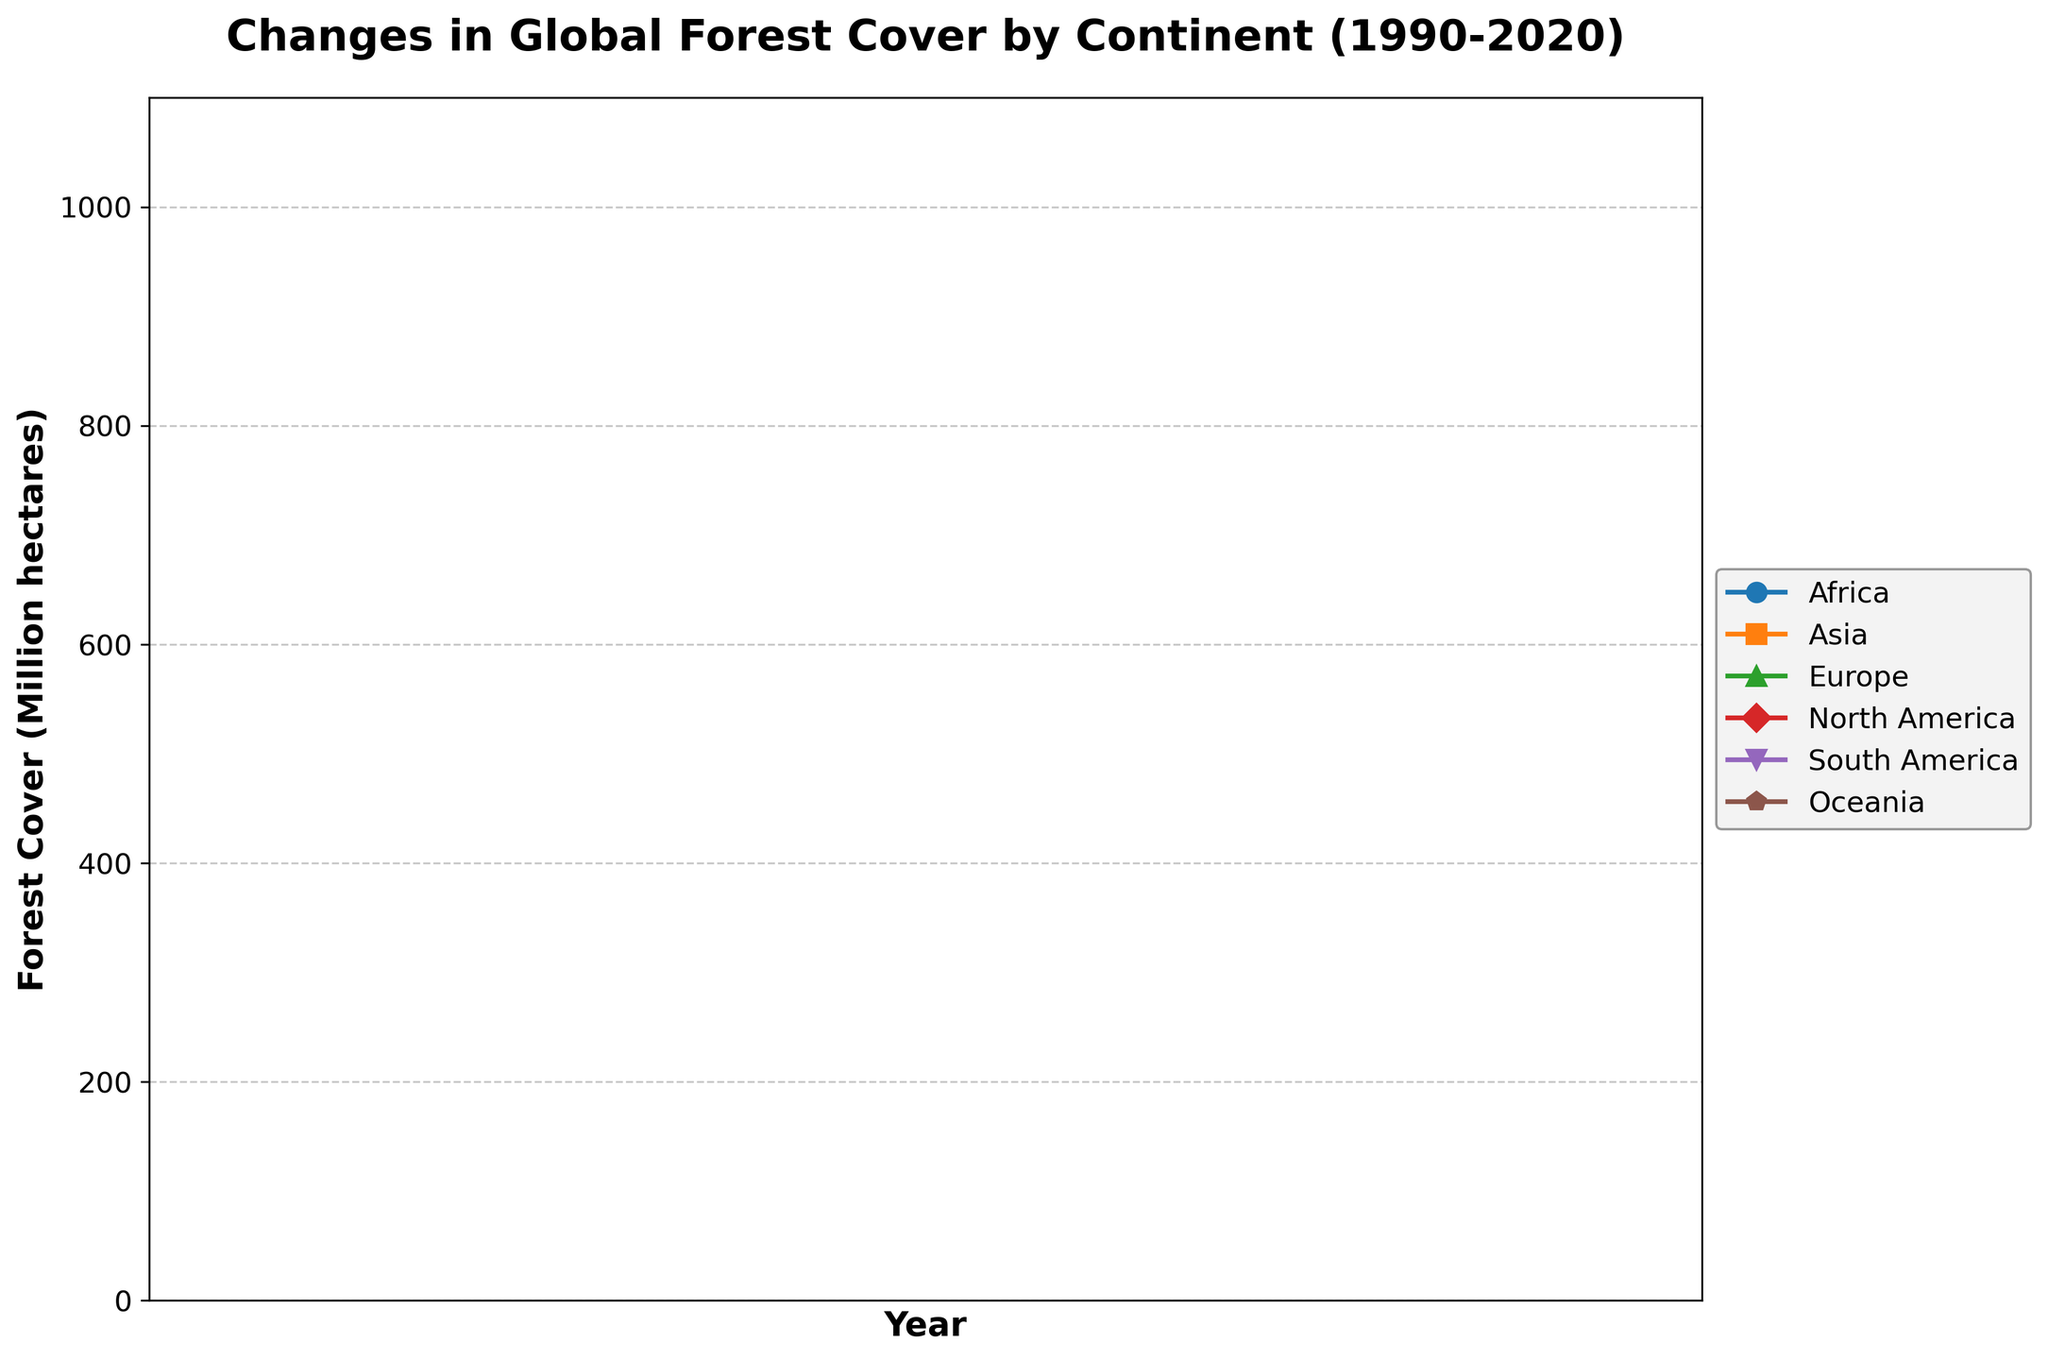What continent experienced the largest decrease in forest cover from 1990 to 2020? To find the continent with the largest decrease, we need to calculate the difference between the forest cover in 1990 and 2020 for each continent. Africa: 749 - 687 = 62, Asia: 618 - 576 = +42 (increase), Europe: 1007 - 989 = +18 (increase), North America: 735 - 723 = +12 (increase), South America: 930 - 844 = 86, Oceania: 182 - 176 = +6 (increase). Antarctica is excluded as its forest cover remains 0. South America experienced the largest decrease (86 million hectares).
Answer: South America Which continent had a consistent increase in forest cover from 1990 to 2020? To determine the continent with a consistent increase, we observe the lines in the graph. Only Asia shows a consistent upward trajectory from 1990 to 2020, indicating an increase in forest cover.
Answer: Asia In what year did Europe have the highest forest cover? By inspecting the data points for Europe, we notice that the forest cover increases consistently over the years. It reaches its highest value in 2020 with 1007 million hectares.
Answer: 2020 Between which consecutive years did Africa experience the greatest loss in forest cover? To find this, we calculate the difference between consecutive years for Africa. 1990-1995: 749-738=11, 1995-2000: 738-727=11, 2000-2005: 727-716=11, 2005-2010: 716-705=11, 2010-2015: 705-696=9, 2015-2020: 696-687=9. The greatest loss of 11 units occurs in multiple periods (1990-1995, 1995-2000, 2000-2005, 2005-2010).
Answer: 1990-1995, 1995-2000, 2000-2005, 2005-2010 What is the total forest cover of Europe and South America combined in 2020? For 2020, Europe has 1007 million hectares, and South America has 844 million hectares. Adding these gives: 1007 + 844 = 1851 million hectares.
Answer: 1851 million hectares Compare the trend in forest cover for Oceania and North America from 1990 to 2020. The graph shows both Oceania and North America experiencing a gradual but consistent increase in forest cover. Oceania increases from 176 million hectares in 1990 to 182 million hectares in 2020, and North America from 723 million hectares in 1990 to 735 million hectares in 2020. Thus, both continents show a positive trend in forest cover.
Answer: Both had an increasing trend Which year showed the most significant difference in forest cover between Africa and Asia? By looking at the differences in forest cover between Africa and Asia for each year: 1990: 749-576=173, 1995: 738-582=156, 2000: 727-589=138, 2005: 716-596=120, 2010: 705-603=102, 2015: 696-610=86, 2020: 687-618=69, the most significant difference is in 1990 with a difference of 173 million hectares.
Answer: 1990 What is the average annual forest cover in North America from 1990 to 2020? To get the average, sum the values for North America from all the years and divide by the number of years: (723 + 725 + 727 + 729 + 731 + 733 + 735) / 7 = 5303 / 7 ≈ 757.57 million hectares.
Answer: 757.57 million hectares 